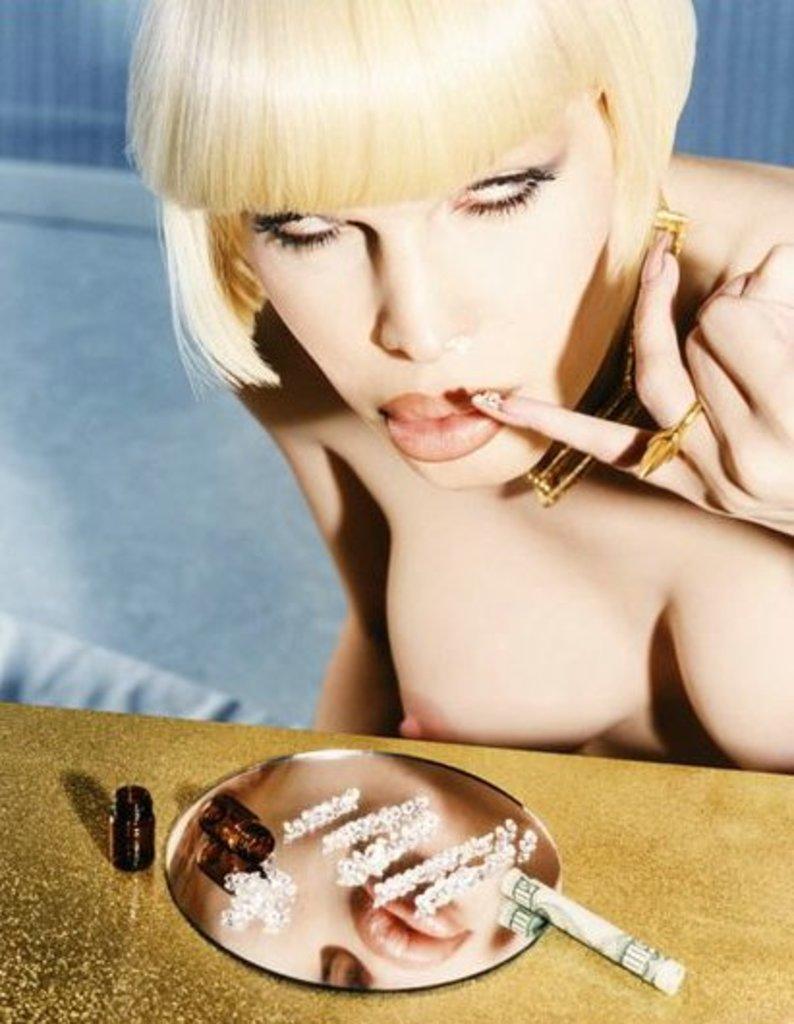In one or two sentences, can you explain what this image depicts? In this image there is women. In front of her there is a table and on top of it there is a mirror and some other object. 